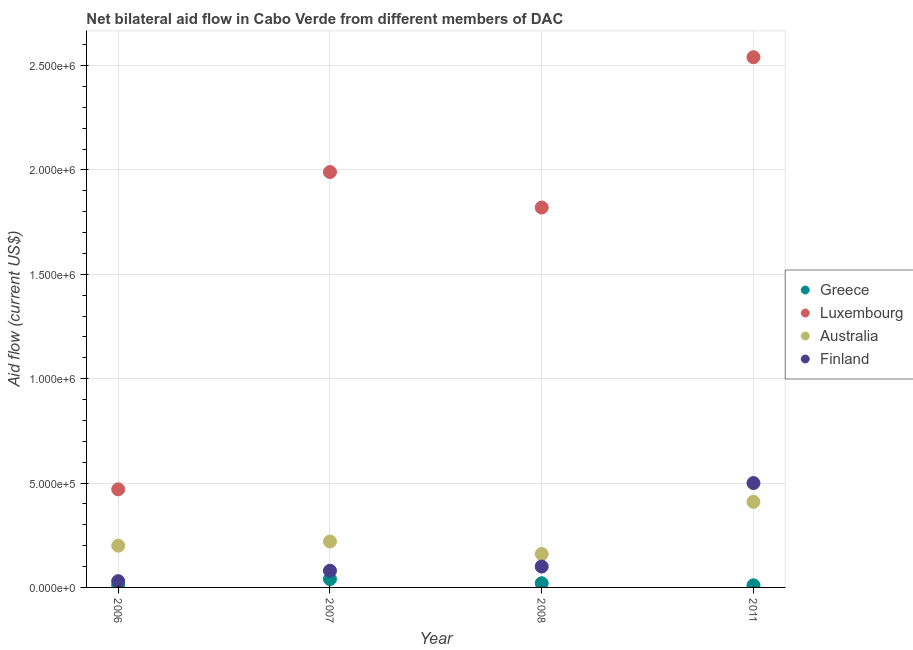How many different coloured dotlines are there?
Provide a short and direct response. 4. Is the number of dotlines equal to the number of legend labels?
Ensure brevity in your answer.  Yes. What is the amount of aid given by greece in 2007?
Provide a succinct answer. 4.00e+04. Across all years, what is the maximum amount of aid given by luxembourg?
Make the answer very short. 2.54e+06. Across all years, what is the minimum amount of aid given by luxembourg?
Provide a short and direct response. 4.70e+05. In which year was the amount of aid given by greece maximum?
Your response must be concise. 2007. What is the total amount of aid given by australia in the graph?
Give a very brief answer. 9.90e+05. What is the difference between the amount of aid given by luxembourg in 2006 and that in 2008?
Provide a short and direct response. -1.35e+06. What is the difference between the amount of aid given by australia in 2007 and the amount of aid given by luxembourg in 2008?
Offer a very short reply. -1.60e+06. In the year 2006, what is the difference between the amount of aid given by greece and amount of aid given by australia?
Ensure brevity in your answer.  -1.90e+05. In how many years, is the amount of aid given by greece greater than 2200000 US$?
Provide a succinct answer. 0. What is the ratio of the amount of aid given by greece in 2006 to that in 2008?
Your answer should be compact. 0.5. Is the amount of aid given by australia in 2006 less than that in 2008?
Your answer should be compact. No. What is the difference between the highest and the second highest amount of aid given by luxembourg?
Offer a terse response. 5.50e+05. What is the difference between the highest and the lowest amount of aid given by australia?
Your answer should be very brief. 2.50e+05. Is the amount of aid given by luxembourg strictly less than the amount of aid given by finland over the years?
Your answer should be compact. No. How many years are there in the graph?
Give a very brief answer. 4. Are the values on the major ticks of Y-axis written in scientific E-notation?
Your answer should be very brief. Yes. Does the graph contain any zero values?
Ensure brevity in your answer.  No. Does the graph contain grids?
Provide a short and direct response. Yes. How many legend labels are there?
Your answer should be very brief. 4. What is the title of the graph?
Provide a succinct answer. Net bilateral aid flow in Cabo Verde from different members of DAC. What is the label or title of the X-axis?
Keep it short and to the point. Year. What is the Aid flow (current US$) in Greece in 2006?
Your response must be concise. 10000. What is the Aid flow (current US$) of Australia in 2006?
Your answer should be very brief. 2.00e+05. What is the Aid flow (current US$) in Finland in 2006?
Provide a succinct answer. 3.00e+04. What is the Aid flow (current US$) of Greece in 2007?
Your response must be concise. 4.00e+04. What is the Aid flow (current US$) of Luxembourg in 2007?
Provide a succinct answer. 1.99e+06. What is the Aid flow (current US$) of Luxembourg in 2008?
Offer a terse response. 1.82e+06. What is the Aid flow (current US$) in Australia in 2008?
Ensure brevity in your answer.  1.60e+05. What is the Aid flow (current US$) in Luxembourg in 2011?
Make the answer very short. 2.54e+06. What is the Aid flow (current US$) of Australia in 2011?
Your response must be concise. 4.10e+05. What is the Aid flow (current US$) of Finland in 2011?
Keep it short and to the point. 5.00e+05. Across all years, what is the maximum Aid flow (current US$) of Greece?
Give a very brief answer. 4.00e+04. Across all years, what is the maximum Aid flow (current US$) in Luxembourg?
Make the answer very short. 2.54e+06. Across all years, what is the maximum Aid flow (current US$) in Australia?
Your answer should be very brief. 4.10e+05. Across all years, what is the maximum Aid flow (current US$) in Finland?
Give a very brief answer. 5.00e+05. Across all years, what is the minimum Aid flow (current US$) of Greece?
Provide a succinct answer. 10000. Across all years, what is the minimum Aid flow (current US$) of Luxembourg?
Keep it short and to the point. 4.70e+05. Across all years, what is the minimum Aid flow (current US$) in Australia?
Give a very brief answer. 1.60e+05. Across all years, what is the minimum Aid flow (current US$) in Finland?
Make the answer very short. 3.00e+04. What is the total Aid flow (current US$) of Greece in the graph?
Offer a very short reply. 8.00e+04. What is the total Aid flow (current US$) of Luxembourg in the graph?
Offer a terse response. 6.82e+06. What is the total Aid flow (current US$) in Australia in the graph?
Provide a succinct answer. 9.90e+05. What is the total Aid flow (current US$) of Finland in the graph?
Your answer should be compact. 7.10e+05. What is the difference between the Aid flow (current US$) of Luxembourg in 2006 and that in 2007?
Ensure brevity in your answer.  -1.52e+06. What is the difference between the Aid flow (current US$) of Australia in 2006 and that in 2007?
Provide a succinct answer. -2.00e+04. What is the difference between the Aid flow (current US$) of Finland in 2006 and that in 2007?
Make the answer very short. -5.00e+04. What is the difference between the Aid flow (current US$) in Greece in 2006 and that in 2008?
Your answer should be very brief. -10000. What is the difference between the Aid flow (current US$) in Luxembourg in 2006 and that in 2008?
Provide a short and direct response. -1.35e+06. What is the difference between the Aid flow (current US$) of Finland in 2006 and that in 2008?
Make the answer very short. -7.00e+04. What is the difference between the Aid flow (current US$) of Luxembourg in 2006 and that in 2011?
Make the answer very short. -2.07e+06. What is the difference between the Aid flow (current US$) of Finland in 2006 and that in 2011?
Your answer should be compact. -4.70e+05. What is the difference between the Aid flow (current US$) in Greece in 2007 and that in 2008?
Provide a short and direct response. 2.00e+04. What is the difference between the Aid flow (current US$) in Luxembourg in 2007 and that in 2008?
Give a very brief answer. 1.70e+05. What is the difference between the Aid flow (current US$) in Australia in 2007 and that in 2008?
Your answer should be compact. 6.00e+04. What is the difference between the Aid flow (current US$) in Luxembourg in 2007 and that in 2011?
Provide a succinct answer. -5.50e+05. What is the difference between the Aid flow (current US$) in Finland in 2007 and that in 2011?
Your answer should be very brief. -4.20e+05. What is the difference between the Aid flow (current US$) of Luxembourg in 2008 and that in 2011?
Offer a very short reply. -7.20e+05. What is the difference between the Aid flow (current US$) in Australia in 2008 and that in 2011?
Your answer should be very brief. -2.50e+05. What is the difference between the Aid flow (current US$) in Finland in 2008 and that in 2011?
Provide a short and direct response. -4.00e+05. What is the difference between the Aid flow (current US$) of Greece in 2006 and the Aid flow (current US$) of Luxembourg in 2007?
Make the answer very short. -1.98e+06. What is the difference between the Aid flow (current US$) of Greece in 2006 and the Aid flow (current US$) of Australia in 2007?
Provide a succinct answer. -2.10e+05. What is the difference between the Aid flow (current US$) in Luxembourg in 2006 and the Aid flow (current US$) in Finland in 2007?
Make the answer very short. 3.90e+05. What is the difference between the Aid flow (current US$) in Greece in 2006 and the Aid flow (current US$) in Luxembourg in 2008?
Keep it short and to the point. -1.81e+06. What is the difference between the Aid flow (current US$) in Greece in 2006 and the Aid flow (current US$) in Australia in 2008?
Provide a succinct answer. -1.50e+05. What is the difference between the Aid flow (current US$) in Greece in 2006 and the Aid flow (current US$) in Finland in 2008?
Keep it short and to the point. -9.00e+04. What is the difference between the Aid flow (current US$) in Luxembourg in 2006 and the Aid flow (current US$) in Australia in 2008?
Keep it short and to the point. 3.10e+05. What is the difference between the Aid flow (current US$) of Greece in 2006 and the Aid flow (current US$) of Luxembourg in 2011?
Provide a succinct answer. -2.53e+06. What is the difference between the Aid flow (current US$) in Greece in 2006 and the Aid flow (current US$) in Australia in 2011?
Your response must be concise. -4.00e+05. What is the difference between the Aid flow (current US$) in Greece in 2006 and the Aid flow (current US$) in Finland in 2011?
Provide a short and direct response. -4.90e+05. What is the difference between the Aid flow (current US$) of Australia in 2006 and the Aid flow (current US$) of Finland in 2011?
Provide a short and direct response. -3.00e+05. What is the difference between the Aid flow (current US$) in Greece in 2007 and the Aid flow (current US$) in Luxembourg in 2008?
Keep it short and to the point. -1.78e+06. What is the difference between the Aid flow (current US$) of Greece in 2007 and the Aid flow (current US$) of Australia in 2008?
Your response must be concise. -1.20e+05. What is the difference between the Aid flow (current US$) of Greece in 2007 and the Aid flow (current US$) of Finland in 2008?
Offer a very short reply. -6.00e+04. What is the difference between the Aid flow (current US$) in Luxembourg in 2007 and the Aid flow (current US$) in Australia in 2008?
Keep it short and to the point. 1.83e+06. What is the difference between the Aid flow (current US$) of Luxembourg in 2007 and the Aid flow (current US$) of Finland in 2008?
Provide a succinct answer. 1.89e+06. What is the difference between the Aid flow (current US$) of Greece in 2007 and the Aid flow (current US$) of Luxembourg in 2011?
Provide a succinct answer. -2.50e+06. What is the difference between the Aid flow (current US$) in Greece in 2007 and the Aid flow (current US$) in Australia in 2011?
Make the answer very short. -3.70e+05. What is the difference between the Aid flow (current US$) of Greece in 2007 and the Aid flow (current US$) of Finland in 2011?
Make the answer very short. -4.60e+05. What is the difference between the Aid flow (current US$) in Luxembourg in 2007 and the Aid flow (current US$) in Australia in 2011?
Keep it short and to the point. 1.58e+06. What is the difference between the Aid flow (current US$) of Luxembourg in 2007 and the Aid flow (current US$) of Finland in 2011?
Provide a succinct answer. 1.49e+06. What is the difference between the Aid flow (current US$) of Australia in 2007 and the Aid flow (current US$) of Finland in 2011?
Your response must be concise. -2.80e+05. What is the difference between the Aid flow (current US$) in Greece in 2008 and the Aid flow (current US$) in Luxembourg in 2011?
Your answer should be very brief. -2.52e+06. What is the difference between the Aid flow (current US$) of Greece in 2008 and the Aid flow (current US$) of Australia in 2011?
Provide a short and direct response. -3.90e+05. What is the difference between the Aid flow (current US$) of Greece in 2008 and the Aid flow (current US$) of Finland in 2011?
Your answer should be very brief. -4.80e+05. What is the difference between the Aid flow (current US$) in Luxembourg in 2008 and the Aid flow (current US$) in Australia in 2011?
Offer a very short reply. 1.41e+06. What is the difference between the Aid flow (current US$) in Luxembourg in 2008 and the Aid flow (current US$) in Finland in 2011?
Your answer should be very brief. 1.32e+06. What is the difference between the Aid flow (current US$) of Australia in 2008 and the Aid flow (current US$) of Finland in 2011?
Keep it short and to the point. -3.40e+05. What is the average Aid flow (current US$) of Luxembourg per year?
Offer a very short reply. 1.70e+06. What is the average Aid flow (current US$) in Australia per year?
Offer a very short reply. 2.48e+05. What is the average Aid flow (current US$) in Finland per year?
Give a very brief answer. 1.78e+05. In the year 2006, what is the difference between the Aid flow (current US$) in Greece and Aid flow (current US$) in Luxembourg?
Keep it short and to the point. -4.60e+05. In the year 2006, what is the difference between the Aid flow (current US$) in Greece and Aid flow (current US$) in Australia?
Provide a short and direct response. -1.90e+05. In the year 2006, what is the difference between the Aid flow (current US$) of Luxembourg and Aid flow (current US$) of Finland?
Your response must be concise. 4.40e+05. In the year 2006, what is the difference between the Aid flow (current US$) in Australia and Aid flow (current US$) in Finland?
Your answer should be very brief. 1.70e+05. In the year 2007, what is the difference between the Aid flow (current US$) of Greece and Aid flow (current US$) of Luxembourg?
Make the answer very short. -1.95e+06. In the year 2007, what is the difference between the Aid flow (current US$) in Greece and Aid flow (current US$) in Finland?
Offer a terse response. -4.00e+04. In the year 2007, what is the difference between the Aid flow (current US$) in Luxembourg and Aid flow (current US$) in Australia?
Ensure brevity in your answer.  1.77e+06. In the year 2007, what is the difference between the Aid flow (current US$) in Luxembourg and Aid flow (current US$) in Finland?
Your answer should be very brief. 1.91e+06. In the year 2008, what is the difference between the Aid flow (current US$) in Greece and Aid flow (current US$) in Luxembourg?
Make the answer very short. -1.80e+06. In the year 2008, what is the difference between the Aid flow (current US$) of Greece and Aid flow (current US$) of Australia?
Keep it short and to the point. -1.40e+05. In the year 2008, what is the difference between the Aid flow (current US$) in Greece and Aid flow (current US$) in Finland?
Your answer should be compact. -8.00e+04. In the year 2008, what is the difference between the Aid flow (current US$) in Luxembourg and Aid flow (current US$) in Australia?
Offer a terse response. 1.66e+06. In the year 2008, what is the difference between the Aid flow (current US$) of Luxembourg and Aid flow (current US$) of Finland?
Offer a very short reply. 1.72e+06. In the year 2011, what is the difference between the Aid flow (current US$) in Greece and Aid flow (current US$) in Luxembourg?
Provide a succinct answer. -2.53e+06. In the year 2011, what is the difference between the Aid flow (current US$) of Greece and Aid flow (current US$) of Australia?
Provide a short and direct response. -4.00e+05. In the year 2011, what is the difference between the Aid flow (current US$) in Greece and Aid flow (current US$) in Finland?
Provide a succinct answer. -4.90e+05. In the year 2011, what is the difference between the Aid flow (current US$) in Luxembourg and Aid flow (current US$) in Australia?
Your answer should be very brief. 2.13e+06. In the year 2011, what is the difference between the Aid flow (current US$) of Luxembourg and Aid flow (current US$) of Finland?
Give a very brief answer. 2.04e+06. In the year 2011, what is the difference between the Aid flow (current US$) in Australia and Aid flow (current US$) in Finland?
Make the answer very short. -9.00e+04. What is the ratio of the Aid flow (current US$) in Luxembourg in 2006 to that in 2007?
Keep it short and to the point. 0.24. What is the ratio of the Aid flow (current US$) in Finland in 2006 to that in 2007?
Your response must be concise. 0.38. What is the ratio of the Aid flow (current US$) in Luxembourg in 2006 to that in 2008?
Offer a terse response. 0.26. What is the ratio of the Aid flow (current US$) in Australia in 2006 to that in 2008?
Offer a very short reply. 1.25. What is the ratio of the Aid flow (current US$) of Finland in 2006 to that in 2008?
Ensure brevity in your answer.  0.3. What is the ratio of the Aid flow (current US$) in Luxembourg in 2006 to that in 2011?
Your response must be concise. 0.18. What is the ratio of the Aid flow (current US$) in Australia in 2006 to that in 2011?
Ensure brevity in your answer.  0.49. What is the ratio of the Aid flow (current US$) in Luxembourg in 2007 to that in 2008?
Make the answer very short. 1.09. What is the ratio of the Aid flow (current US$) in Australia in 2007 to that in 2008?
Provide a short and direct response. 1.38. What is the ratio of the Aid flow (current US$) of Luxembourg in 2007 to that in 2011?
Give a very brief answer. 0.78. What is the ratio of the Aid flow (current US$) of Australia in 2007 to that in 2011?
Your answer should be compact. 0.54. What is the ratio of the Aid flow (current US$) of Finland in 2007 to that in 2011?
Offer a very short reply. 0.16. What is the ratio of the Aid flow (current US$) of Greece in 2008 to that in 2011?
Offer a terse response. 2. What is the ratio of the Aid flow (current US$) in Luxembourg in 2008 to that in 2011?
Offer a very short reply. 0.72. What is the ratio of the Aid flow (current US$) of Australia in 2008 to that in 2011?
Keep it short and to the point. 0.39. What is the ratio of the Aid flow (current US$) in Finland in 2008 to that in 2011?
Offer a terse response. 0.2. What is the difference between the highest and the second highest Aid flow (current US$) of Greece?
Keep it short and to the point. 2.00e+04. What is the difference between the highest and the second highest Aid flow (current US$) in Luxembourg?
Offer a terse response. 5.50e+05. What is the difference between the highest and the second highest Aid flow (current US$) in Finland?
Offer a terse response. 4.00e+05. What is the difference between the highest and the lowest Aid flow (current US$) in Luxembourg?
Keep it short and to the point. 2.07e+06. 